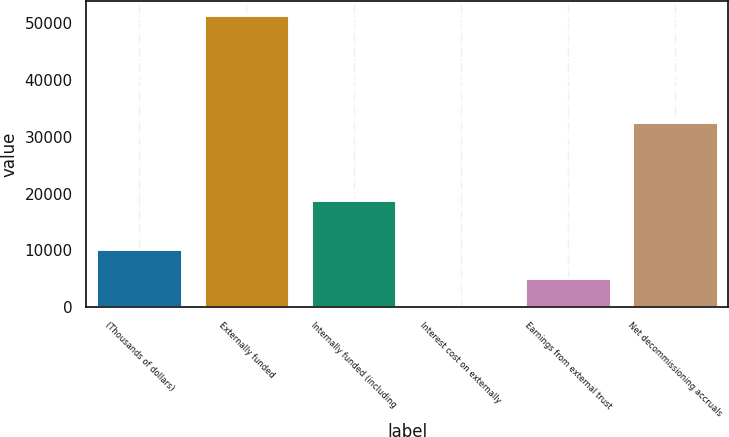Convert chart. <chart><loc_0><loc_0><loc_500><loc_500><bar_chart><fcel>(Thousands of dollars)<fcel>Externally funded<fcel>Internally funded (including<fcel>Interest cost on externally<fcel>Earnings from external trust<fcel>Net decommissioning accruals<nl><fcel>10312.2<fcel>51433<fcel>18797<fcel>32<fcel>5172.1<fcel>32636<nl></chart> 